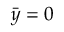Convert formula to latex. <formula><loc_0><loc_0><loc_500><loc_500>\bar { y } = 0</formula> 